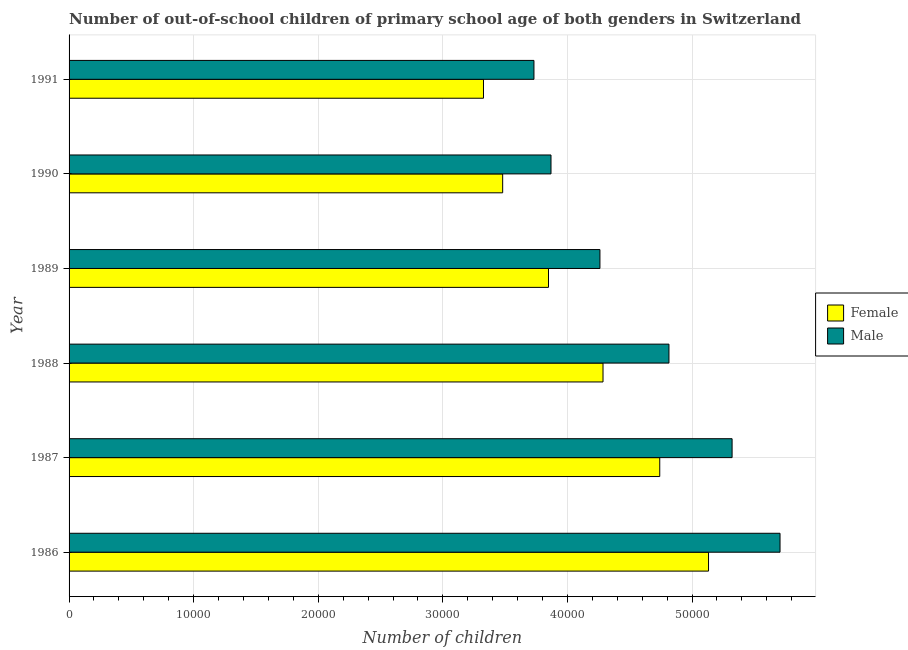How many different coloured bars are there?
Make the answer very short. 2. How many groups of bars are there?
Offer a very short reply. 6. Are the number of bars per tick equal to the number of legend labels?
Keep it short and to the point. Yes. Are the number of bars on each tick of the Y-axis equal?
Your answer should be very brief. Yes. How many bars are there on the 3rd tick from the bottom?
Keep it short and to the point. 2. What is the label of the 6th group of bars from the top?
Provide a short and direct response. 1986. What is the number of female out-of-school students in 1989?
Offer a very short reply. 3.85e+04. Across all years, what is the maximum number of male out-of-school students?
Give a very brief answer. 5.71e+04. Across all years, what is the minimum number of male out-of-school students?
Ensure brevity in your answer.  3.73e+04. What is the total number of female out-of-school students in the graph?
Make the answer very short. 2.48e+05. What is the difference between the number of female out-of-school students in 1988 and that in 1991?
Make the answer very short. 9594. What is the difference between the number of male out-of-school students in 1988 and the number of female out-of-school students in 1986?
Your answer should be very brief. -3177. What is the average number of female out-of-school students per year?
Provide a succinct answer. 4.14e+04. In the year 1990, what is the difference between the number of female out-of-school students and number of male out-of-school students?
Your answer should be compact. -3879. In how many years, is the number of female out-of-school students greater than 24000 ?
Your answer should be compact. 6. What is the ratio of the number of female out-of-school students in 1989 to that in 1991?
Your response must be concise. 1.16. What is the difference between the highest and the second highest number of male out-of-school students?
Make the answer very short. 3848. What is the difference between the highest and the lowest number of male out-of-school students?
Ensure brevity in your answer.  1.98e+04. In how many years, is the number of male out-of-school students greater than the average number of male out-of-school students taken over all years?
Make the answer very short. 3. How many bars are there?
Your answer should be compact. 12. How many years are there in the graph?
Your answer should be very brief. 6. What is the difference between two consecutive major ticks on the X-axis?
Provide a succinct answer. 10000. Are the values on the major ticks of X-axis written in scientific E-notation?
Your answer should be very brief. No. Does the graph contain any zero values?
Ensure brevity in your answer.  No. Does the graph contain grids?
Give a very brief answer. Yes. What is the title of the graph?
Ensure brevity in your answer.  Number of out-of-school children of primary school age of both genders in Switzerland. Does "Non-pregnant women" appear as one of the legend labels in the graph?
Give a very brief answer. No. What is the label or title of the X-axis?
Offer a terse response. Number of children. What is the Number of children in Female in 1986?
Give a very brief answer. 5.13e+04. What is the Number of children in Male in 1986?
Give a very brief answer. 5.71e+04. What is the Number of children of Female in 1987?
Offer a very short reply. 4.74e+04. What is the Number of children of Male in 1987?
Make the answer very short. 5.32e+04. What is the Number of children in Female in 1988?
Your response must be concise. 4.29e+04. What is the Number of children of Male in 1988?
Your response must be concise. 4.81e+04. What is the Number of children in Female in 1989?
Keep it short and to the point. 3.85e+04. What is the Number of children of Male in 1989?
Keep it short and to the point. 4.26e+04. What is the Number of children of Female in 1990?
Keep it short and to the point. 3.48e+04. What is the Number of children in Male in 1990?
Provide a short and direct response. 3.87e+04. What is the Number of children in Female in 1991?
Offer a terse response. 3.33e+04. What is the Number of children of Male in 1991?
Your answer should be compact. 3.73e+04. Across all years, what is the maximum Number of children of Female?
Your answer should be compact. 5.13e+04. Across all years, what is the maximum Number of children of Male?
Your response must be concise. 5.71e+04. Across all years, what is the minimum Number of children of Female?
Offer a terse response. 3.33e+04. Across all years, what is the minimum Number of children of Male?
Make the answer very short. 3.73e+04. What is the total Number of children of Female in the graph?
Give a very brief answer. 2.48e+05. What is the total Number of children in Male in the graph?
Offer a very short reply. 2.77e+05. What is the difference between the Number of children of Female in 1986 and that in 1987?
Your response must be concise. 3916. What is the difference between the Number of children of Male in 1986 and that in 1987?
Offer a terse response. 3848. What is the difference between the Number of children of Female in 1986 and that in 1988?
Provide a succinct answer. 8469. What is the difference between the Number of children of Male in 1986 and that in 1988?
Offer a terse response. 8916. What is the difference between the Number of children of Female in 1986 and that in 1989?
Your response must be concise. 1.28e+04. What is the difference between the Number of children of Male in 1986 and that in 1989?
Give a very brief answer. 1.45e+04. What is the difference between the Number of children in Female in 1986 and that in 1990?
Give a very brief answer. 1.65e+04. What is the difference between the Number of children of Male in 1986 and that in 1990?
Your answer should be compact. 1.84e+04. What is the difference between the Number of children in Female in 1986 and that in 1991?
Offer a terse response. 1.81e+04. What is the difference between the Number of children in Male in 1986 and that in 1991?
Provide a succinct answer. 1.98e+04. What is the difference between the Number of children in Female in 1987 and that in 1988?
Provide a succinct answer. 4553. What is the difference between the Number of children in Male in 1987 and that in 1988?
Keep it short and to the point. 5068. What is the difference between the Number of children in Female in 1987 and that in 1989?
Keep it short and to the point. 8929. What is the difference between the Number of children of Male in 1987 and that in 1989?
Provide a short and direct response. 1.06e+04. What is the difference between the Number of children in Female in 1987 and that in 1990?
Provide a short and direct response. 1.26e+04. What is the difference between the Number of children in Male in 1987 and that in 1990?
Keep it short and to the point. 1.45e+04. What is the difference between the Number of children of Female in 1987 and that in 1991?
Your answer should be very brief. 1.41e+04. What is the difference between the Number of children of Male in 1987 and that in 1991?
Offer a terse response. 1.59e+04. What is the difference between the Number of children of Female in 1988 and that in 1989?
Give a very brief answer. 4376. What is the difference between the Number of children of Male in 1988 and that in 1989?
Offer a very short reply. 5539. What is the difference between the Number of children of Female in 1988 and that in 1990?
Your response must be concise. 8054. What is the difference between the Number of children of Male in 1988 and that in 1990?
Ensure brevity in your answer.  9467. What is the difference between the Number of children in Female in 1988 and that in 1991?
Your answer should be compact. 9594. What is the difference between the Number of children in Male in 1988 and that in 1991?
Provide a short and direct response. 1.08e+04. What is the difference between the Number of children of Female in 1989 and that in 1990?
Offer a very short reply. 3678. What is the difference between the Number of children in Male in 1989 and that in 1990?
Offer a terse response. 3928. What is the difference between the Number of children in Female in 1989 and that in 1991?
Keep it short and to the point. 5218. What is the difference between the Number of children of Male in 1989 and that in 1991?
Ensure brevity in your answer.  5296. What is the difference between the Number of children in Female in 1990 and that in 1991?
Offer a terse response. 1540. What is the difference between the Number of children of Male in 1990 and that in 1991?
Provide a short and direct response. 1368. What is the difference between the Number of children of Female in 1986 and the Number of children of Male in 1987?
Offer a terse response. -1891. What is the difference between the Number of children in Female in 1986 and the Number of children in Male in 1988?
Your answer should be compact. 3177. What is the difference between the Number of children in Female in 1986 and the Number of children in Male in 1989?
Make the answer very short. 8716. What is the difference between the Number of children in Female in 1986 and the Number of children in Male in 1990?
Your answer should be compact. 1.26e+04. What is the difference between the Number of children in Female in 1986 and the Number of children in Male in 1991?
Your answer should be very brief. 1.40e+04. What is the difference between the Number of children of Female in 1987 and the Number of children of Male in 1988?
Your response must be concise. -739. What is the difference between the Number of children in Female in 1987 and the Number of children in Male in 1989?
Your response must be concise. 4800. What is the difference between the Number of children of Female in 1987 and the Number of children of Male in 1990?
Provide a short and direct response. 8728. What is the difference between the Number of children in Female in 1987 and the Number of children in Male in 1991?
Provide a succinct answer. 1.01e+04. What is the difference between the Number of children of Female in 1988 and the Number of children of Male in 1989?
Provide a succinct answer. 247. What is the difference between the Number of children in Female in 1988 and the Number of children in Male in 1990?
Provide a short and direct response. 4175. What is the difference between the Number of children in Female in 1988 and the Number of children in Male in 1991?
Ensure brevity in your answer.  5543. What is the difference between the Number of children in Female in 1989 and the Number of children in Male in 1990?
Keep it short and to the point. -201. What is the difference between the Number of children in Female in 1989 and the Number of children in Male in 1991?
Your answer should be very brief. 1167. What is the difference between the Number of children in Female in 1990 and the Number of children in Male in 1991?
Keep it short and to the point. -2511. What is the average Number of children of Female per year?
Offer a terse response. 4.14e+04. What is the average Number of children in Male per year?
Provide a short and direct response. 4.62e+04. In the year 1986, what is the difference between the Number of children in Female and Number of children in Male?
Give a very brief answer. -5739. In the year 1987, what is the difference between the Number of children in Female and Number of children in Male?
Ensure brevity in your answer.  -5807. In the year 1988, what is the difference between the Number of children of Female and Number of children of Male?
Keep it short and to the point. -5292. In the year 1989, what is the difference between the Number of children in Female and Number of children in Male?
Keep it short and to the point. -4129. In the year 1990, what is the difference between the Number of children in Female and Number of children in Male?
Your answer should be compact. -3879. In the year 1991, what is the difference between the Number of children in Female and Number of children in Male?
Provide a short and direct response. -4051. What is the ratio of the Number of children of Female in 1986 to that in 1987?
Provide a short and direct response. 1.08. What is the ratio of the Number of children in Male in 1986 to that in 1987?
Offer a terse response. 1.07. What is the ratio of the Number of children in Female in 1986 to that in 1988?
Your response must be concise. 1.2. What is the ratio of the Number of children in Male in 1986 to that in 1988?
Provide a short and direct response. 1.19. What is the ratio of the Number of children in Female in 1986 to that in 1989?
Offer a very short reply. 1.33. What is the ratio of the Number of children of Male in 1986 to that in 1989?
Your answer should be very brief. 1.34. What is the ratio of the Number of children in Female in 1986 to that in 1990?
Your answer should be compact. 1.47. What is the ratio of the Number of children in Male in 1986 to that in 1990?
Keep it short and to the point. 1.48. What is the ratio of the Number of children of Female in 1986 to that in 1991?
Give a very brief answer. 1.54. What is the ratio of the Number of children in Male in 1986 to that in 1991?
Your answer should be very brief. 1.53. What is the ratio of the Number of children in Female in 1987 to that in 1988?
Your response must be concise. 1.11. What is the ratio of the Number of children of Male in 1987 to that in 1988?
Offer a very short reply. 1.11. What is the ratio of the Number of children in Female in 1987 to that in 1989?
Your answer should be very brief. 1.23. What is the ratio of the Number of children of Male in 1987 to that in 1989?
Offer a terse response. 1.25. What is the ratio of the Number of children in Female in 1987 to that in 1990?
Your response must be concise. 1.36. What is the ratio of the Number of children in Male in 1987 to that in 1990?
Your response must be concise. 1.38. What is the ratio of the Number of children in Female in 1987 to that in 1991?
Provide a short and direct response. 1.43. What is the ratio of the Number of children of Male in 1987 to that in 1991?
Keep it short and to the point. 1.43. What is the ratio of the Number of children of Female in 1988 to that in 1989?
Give a very brief answer. 1.11. What is the ratio of the Number of children in Male in 1988 to that in 1989?
Offer a terse response. 1.13. What is the ratio of the Number of children in Female in 1988 to that in 1990?
Make the answer very short. 1.23. What is the ratio of the Number of children of Male in 1988 to that in 1990?
Give a very brief answer. 1.24. What is the ratio of the Number of children of Female in 1988 to that in 1991?
Give a very brief answer. 1.29. What is the ratio of the Number of children in Male in 1988 to that in 1991?
Give a very brief answer. 1.29. What is the ratio of the Number of children in Female in 1989 to that in 1990?
Provide a short and direct response. 1.11. What is the ratio of the Number of children of Male in 1989 to that in 1990?
Offer a terse response. 1.1. What is the ratio of the Number of children of Female in 1989 to that in 1991?
Your response must be concise. 1.16. What is the ratio of the Number of children of Male in 1989 to that in 1991?
Your response must be concise. 1.14. What is the ratio of the Number of children in Female in 1990 to that in 1991?
Your answer should be compact. 1.05. What is the ratio of the Number of children of Male in 1990 to that in 1991?
Keep it short and to the point. 1.04. What is the difference between the highest and the second highest Number of children of Female?
Provide a short and direct response. 3916. What is the difference between the highest and the second highest Number of children in Male?
Ensure brevity in your answer.  3848. What is the difference between the highest and the lowest Number of children in Female?
Keep it short and to the point. 1.81e+04. What is the difference between the highest and the lowest Number of children of Male?
Give a very brief answer. 1.98e+04. 